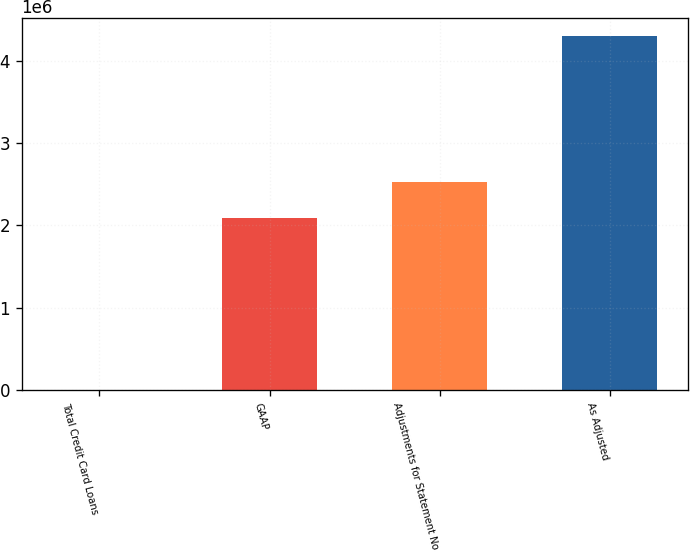Convert chart. <chart><loc_0><loc_0><loc_500><loc_500><bar_chart><fcel>Total Credit Card Loans<fcel>GAAP<fcel>Adjustments for Statement No<fcel>As Adjusted<nl><fcel>2009<fcel>2.09657e+06<fcel>2.52683e+06<fcel>4.30461e+06<nl></chart> 